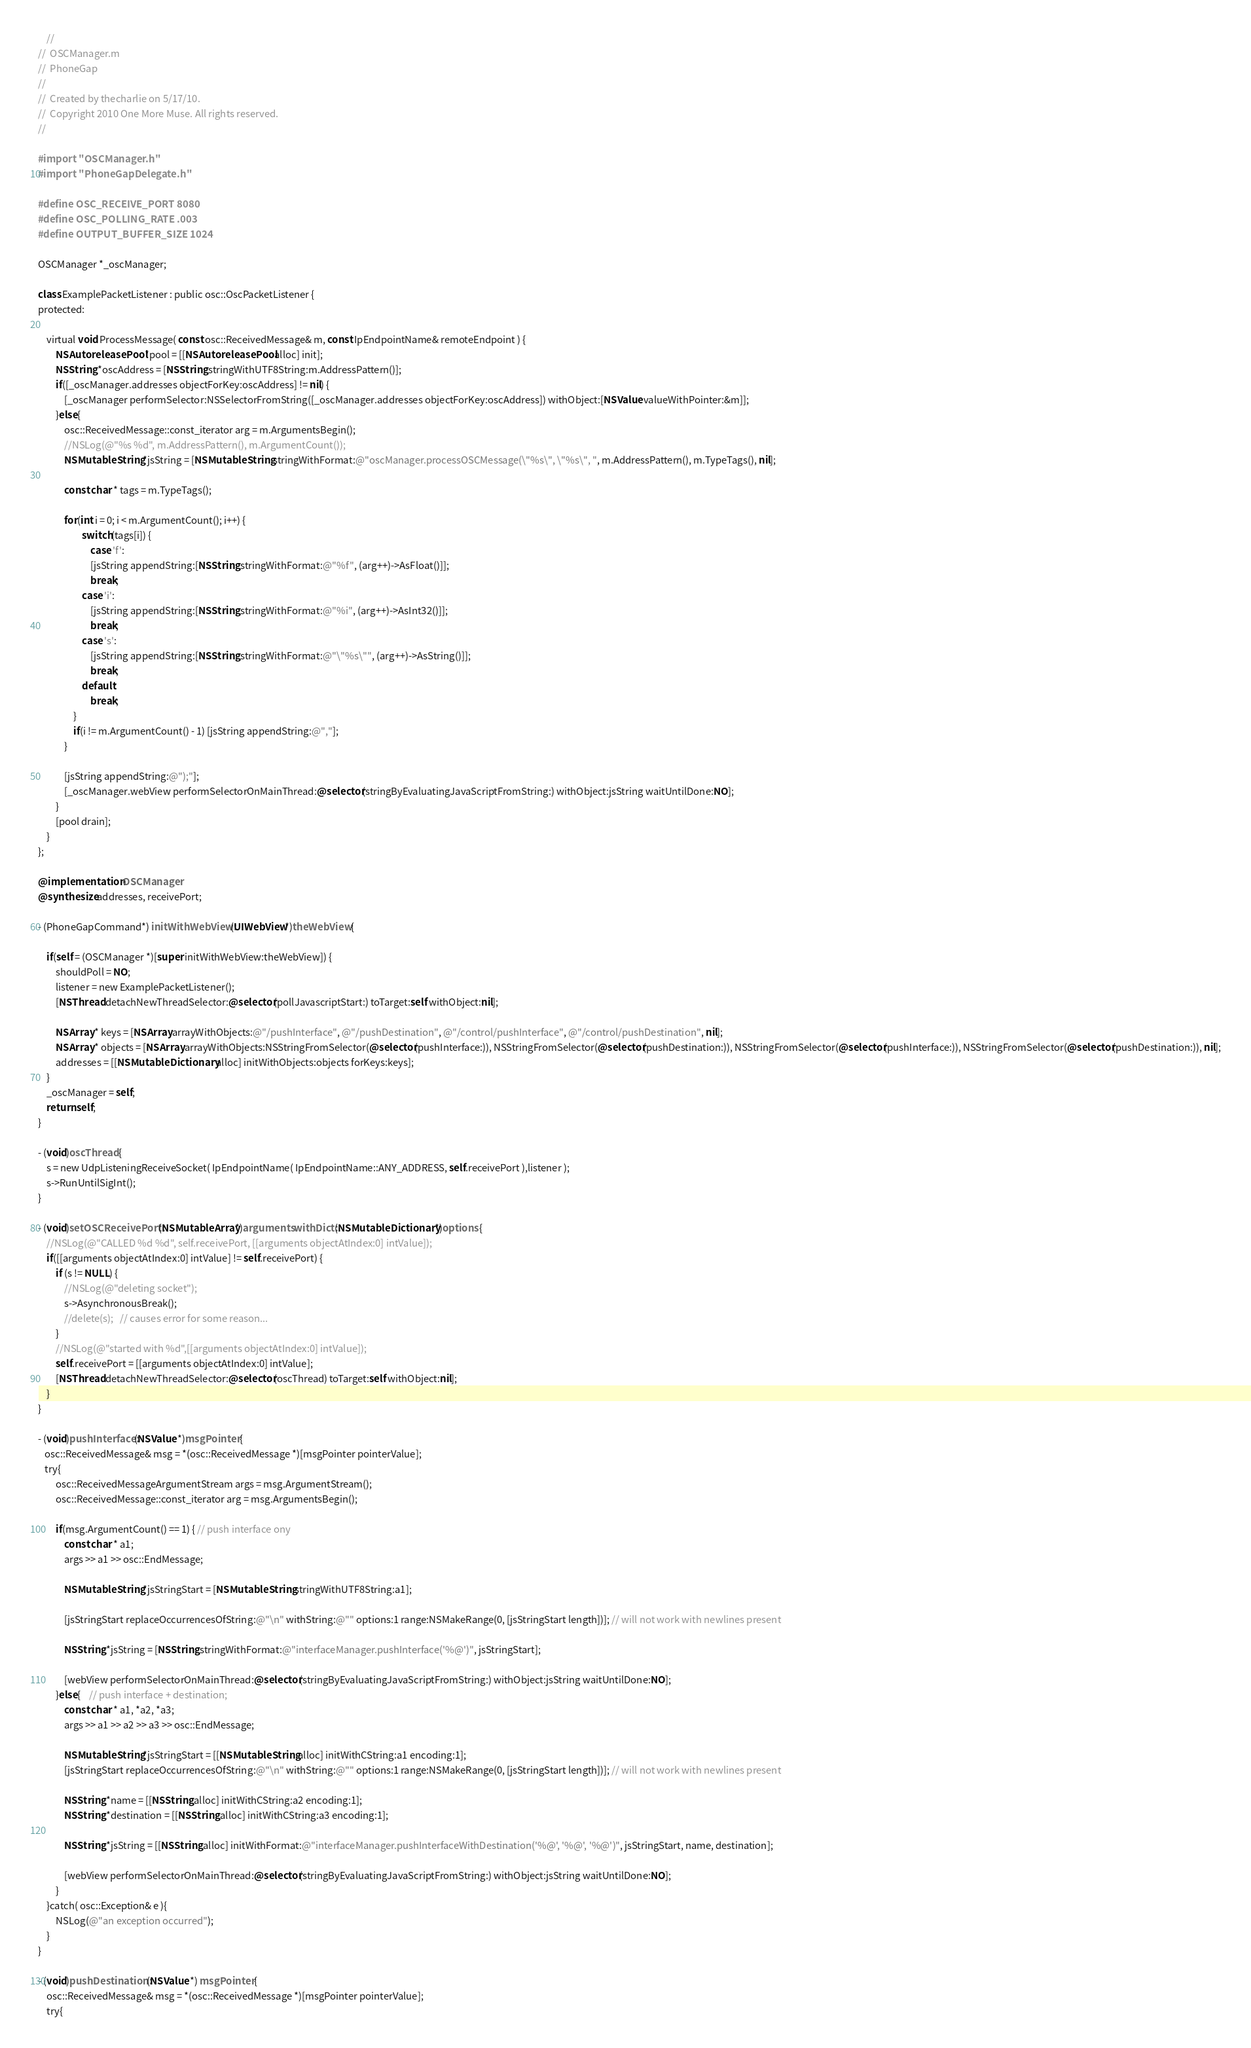<code> <loc_0><loc_0><loc_500><loc_500><_ObjectiveC_>    //
//  OSCManager.m
//  PhoneGap
//
//  Created by thecharlie on 5/17/10.
//  Copyright 2010 One More Muse. All rights reserved.
//

#import "OSCManager.h"
#import "PhoneGapDelegate.h"

#define OSC_RECEIVE_PORT 8080
#define OSC_POLLING_RATE .003
#define OUTPUT_BUFFER_SIZE 1024

OSCManager *_oscManager;

class ExamplePacketListener : public osc::OscPacketListener {
protected:

    virtual void ProcessMessage( const osc::ReceivedMessage& m, const IpEndpointName& remoteEndpoint ) {
		NSAutoreleasePool *pool = [[NSAutoreleasePool alloc] init];
		NSString *oscAddress = [NSString stringWithUTF8String:m.AddressPattern()];
		if([_oscManager.addresses objectForKey:oscAddress] != nil) {			
			[_oscManager performSelector:NSSelectorFromString([_oscManager.addresses objectForKey:oscAddress]) withObject:[NSValue valueWithPointer:&m]];
		}else{
			osc::ReceivedMessage::const_iterator arg = m.ArgumentsBegin();
			//NSLog(@"%s %d", m.AddressPattern(), m.ArgumentCount());
			NSMutableString *jsString = [NSMutableString stringWithFormat:@"oscManager.processOSCMessage(\"%s\", \"%s\", ", m.AddressPattern(), m.TypeTags(), nil];

			const char * tags = m.TypeTags();

			for(int i = 0; i < m.ArgumentCount(); i++) {
					switch(tags[i]) {
						case 'f':
						[jsString appendString:[NSString stringWithFormat:@"%f", (arg++)->AsFloat()]];
						break;
					case 'i':
						[jsString appendString:[NSString stringWithFormat:@"%i", (arg++)->AsInt32()]];						
						break;
					case 's':
						[jsString appendString:[NSString stringWithFormat:@"\"%s\"", (arg++)->AsString()]];
						break;
					default:
						break;
				}
				if(i != m.ArgumentCount() - 1) [jsString appendString:@","];
			}
			
			[jsString appendString:@");"];
			[_oscManager.webView performSelectorOnMainThread:@selector(stringByEvaluatingJavaScriptFromString:) withObject:jsString waitUntilDone:NO];
		}
		[pool drain];
	}
};

@implementation OSCManager
@synthesize addresses, receivePort;

- (PhoneGapCommand*) initWithWebView:(UIWebView*)theWebView {

	if(self = (OSCManager *)[super initWithWebView:theWebView]) {
        shouldPoll = NO;
		listener = new ExamplePacketListener();
		[NSThread detachNewThreadSelector:@selector(pollJavascriptStart:) toTarget:self withObject:nil];
		
		NSArray * keys = [NSArray arrayWithObjects:@"/pushInterface", @"/pushDestination", @"/control/pushInterface", @"/control/pushDestination", nil];
		NSArray * objects = [NSArray arrayWithObjects:NSStringFromSelector(@selector(pushInterface:)), NSStringFromSelector(@selector(pushDestination:)), NSStringFromSelector(@selector(pushInterface:)), NSStringFromSelector(@selector(pushDestination:)), nil];
		addresses = [[NSMutableDictionary alloc] initWithObjects:objects forKeys:keys];		
	}
	_oscManager = self;
	return self;
}

- (void)oscThread {	
	s = new UdpListeningReceiveSocket( IpEndpointName( IpEndpointName::ANY_ADDRESS, self.receivePort ),listener );
	s->RunUntilSigInt();
}

- (void)setOSCReceivePort:(NSMutableArray*)arguments withDict:(NSMutableDictionary*)options {
    //NSLog(@"CALLED %d %d", self.receivePort, [[arguments objectAtIndex:0] intValue]);
	if([[arguments objectAtIndex:0] intValue] != self.receivePort) {
        if (s != NULL) {
            //NSLog(@"deleting socket");
            s->AsynchronousBreak();
            //delete(s);   // causes error for some reason...
        }
        //NSLog(@"started with %d",[[arguments objectAtIndex:0] intValue]);
		self.receivePort = [[arguments objectAtIndex:0] intValue];
		[NSThread detachNewThreadSelector:@selector(oscThread) toTarget:self withObject:nil];
	}
}

- (void)pushInterface:(NSValue *)msgPointer {
   osc::ReceivedMessage& msg = *(osc::ReceivedMessage *)[msgPointer pointerValue];
   try{
		osc::ReceivedMessageArgumentStream args = msg.ArgumentStream();
		osc::ReceivedMessage::const_iterator arg = msg.ArgumentsBegin();
				
		if(msg.ArgumentCount() == 1) { // push interface ony
			const char * a1;
			args >> a1 >> osc::EndMessage;
				
			NSMutableString *jsStringStart = [NSMutableString stringWithUTF8String:a1];
			
			[jsStringStart replaceOccurrencesOfString:@"\n" withString:@"" options:1 range:NSMakeRange(0, [jsStringStart length])]; // will not work with newlines present
			
			NSString *jsString = [NSString stringWithFormat:@"interfaceManager.pushInterface('%@')", jsStringStart];

			[webView performSelectorOnMainThread:@selector(stringByEvaluatingJavaScriptFromString:) withObject:jsString waitUntilDone:NO];
		}else{	// push interface + destination;
			const char * a1, *a2, *a3;
			args >> a1 >> a2 >> a3 >> osc::EndMessage;

			NSMutableString *jsStringStart = [[NSMutableString alloc] initWithCString:a1 encoding:1];
			[jsStringStart replaceOccurrencesOfString:@"\n" withString:@"" options:1 range:NSMakeRange(0, [jsStringStart length])]; // will not work with newlines present
			
			NSString *name = [[NSString alloc] initWithCString:a2 encoding:1];
			NSString *destination = [[NSString alloc] initWithCString:a3 encoding:1];

			NSString *jsString = [[NSString alloc] initWithFormat:@"interfaceManager.pushInterfaceWithDestination('%@', '%@', '%@')", jsStringStart, name, destination];
			
			[webView performSelectorOnMainThread:@selector(stringByEvaluatingJavaScriptFromString:) withObject:jsString waitUntilDone:NO];
		}
	}catch( osc::Exception& e ){
		NSLog(@"an exception occurred");
	}
}

- (void)pushDestination:(NSValue *) msgPointer {
	osc::ReceivedMessage& msg = *(osc::ReceivedMessage *)[msgPointer pointerValue];
	try{</code> 